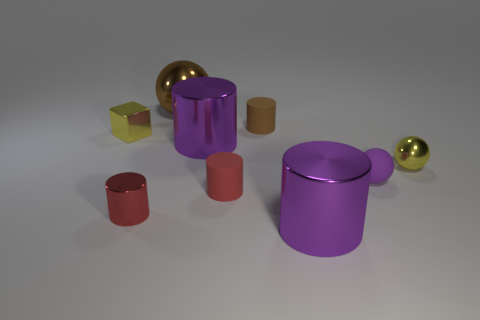There is a small purple rubber thing; what number of purple metal things are in front of it?
Make the answer very short. 1. How many tiny yellow objects are made of the same material as the yellow ball?
Keep it short and to the point. 1. Are the red cylinder that is on the left side of the big metallic ball and the big brown thing made of the same material?
Make the answer very short. Yes. Are there any small rubber blocks?
Your response must be concise. No. There is a cylinder that is on the left side of the red rubber cylinder and behind the yellow metal ball; how big is it?
Offer a very short reply. Large. Are there more big things on the right side of the brown metal sphere than big brown shiny things that are on the left side of the small cube?
Provide a short and direct response. Yes. What is the color of the small shiny sphere?
Keep it short and to the point. Yellow. There is a small shiny object that is behind the small red matte thing and to the right of the yellow metallic block; what is its color?
Your response must be concise. Yellow. What is the color of the shiny ball left of the small purple matte ball that is in front of the tiny brown thing behind the rubber sphere?
Ensure brevity in your answer.  Brown. There is a metal sphere that is the same size as the yellow metal block; what is its color?
Keep it short and to the point. Yellow. 